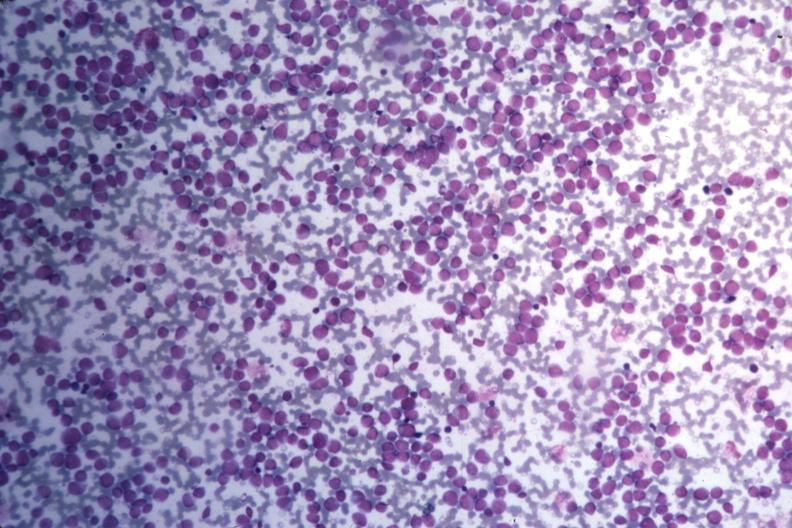does serous cyst show med wrights stain many pleomorphic blast cells readily seen?
Answer the question using a single word or phrase. No 